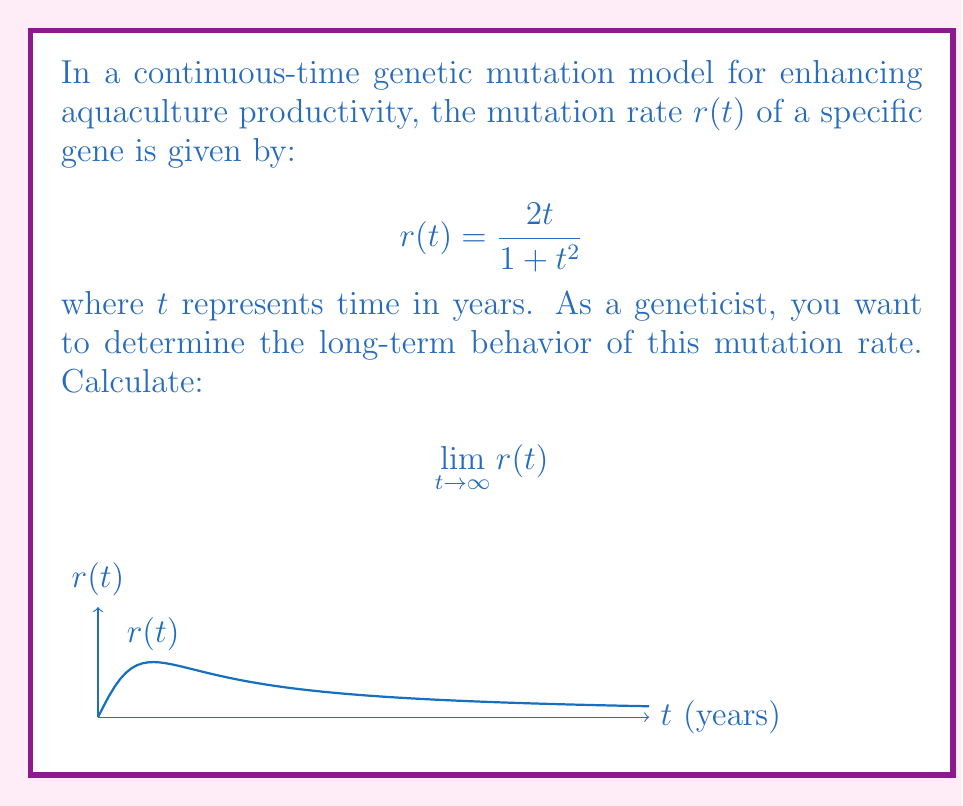Help me with this question. To find the limit of $r(t)$ as $t$ approaches infinity, we can follow these steps:

1) First, let's examine the function:
   $$r(t) = \frac{2t}{1+t^2}$$

2) To evaluate the limit as $t \to \infty$, we can divide both numerator and denominator by the highest power of $t$ in the denominator, which is $t^2$:

   $$\lim_{t \to \infty} r(t) = \lim_{t \to \infty} \frac{2t}{1+t^2} = \lim_{t \to \infty} \frac{2t/t^2}{(1+t^2)/t^2}$$

3) Simplify:
   $$\lim_{t \to \infty} \frac{2/t}{1/t^2 + 1}$$

4) As $t$ approaches infinity:
   - $2/t$ approaches 0
   - $1/t^2$ approaches 0
   - The constant 1 remains unchanged

5) Therefore:
   $$\lim_{t \to \infty} r(t) = \frac{0}{0 + 1} = 0$$

This result indicates that in this model, the mutation rate approaches zero as time goes to infinity, suggesting a stabilization of the genetic makeup in the long term.
Answer: 0 